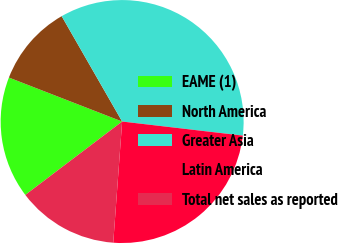<chart> <loc_0><loc_0><loc_500><loc_500><pie_chart><fcel>EAME (1)<fcel>North America<fcel>Greater Asia<fcel>Latin America<fcel>Total net sales as reported<nl><fcel>16.22%<fcel>10.81%<fcel>35.14%<fcel>24.32%<fcel>13.51%<nl></chart> 